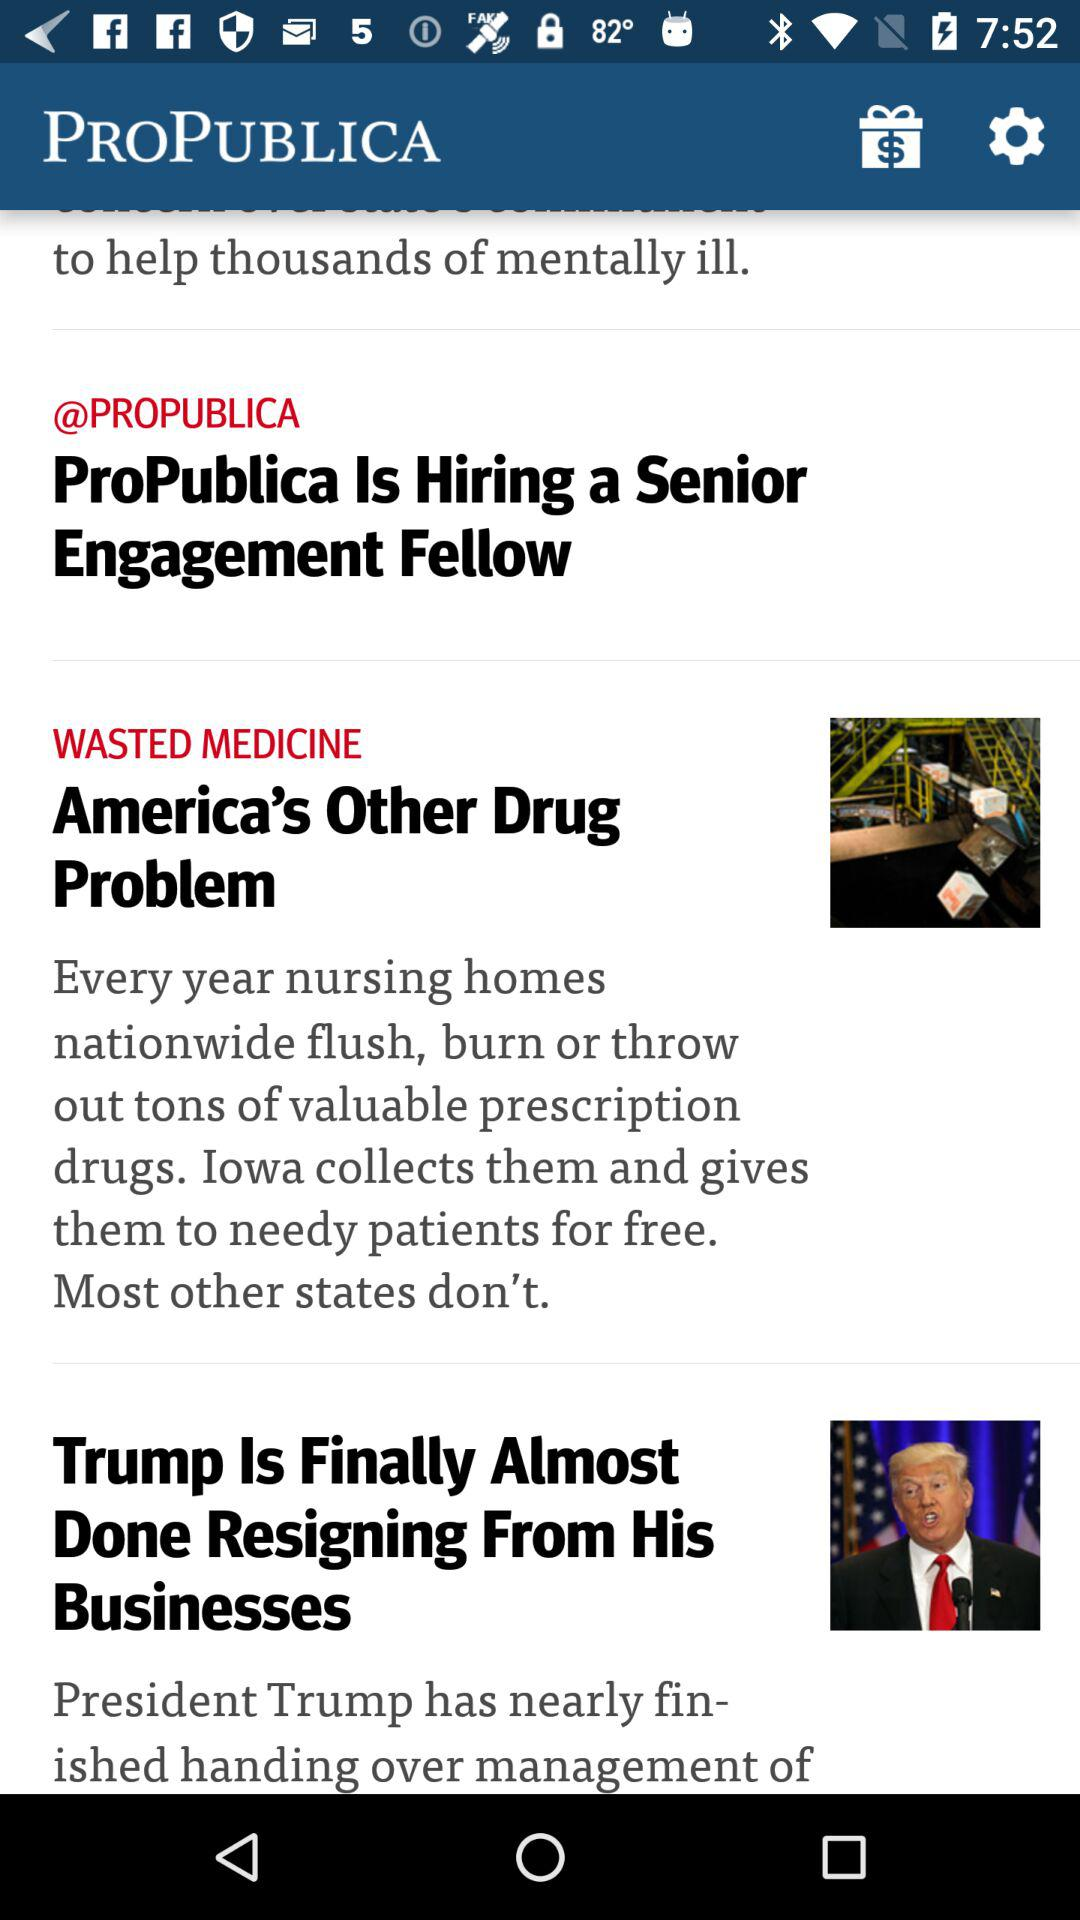How many stories are there in this article?
Answer the question using a single word or phrase. 3 